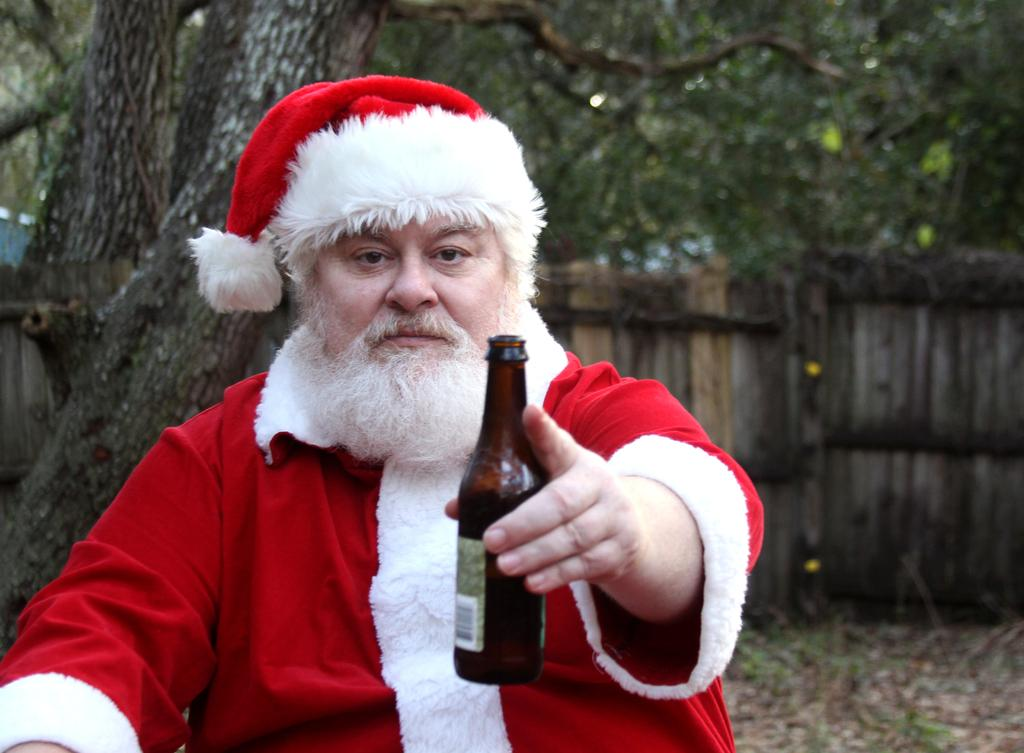Who is present in the image? There is a man in the image. What is the man wearing? The man is wearing a fancy dress. What is the man holding in the image? The man is holding a bottle. What can be seen in the background of the image? There is a tree in the background of the image. What is the purpose of the oil in the image? There is no oil present in the image, so it is not possible to determine its purpose. 